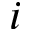<formula> <loc_0><loc_0><loc_500><loc_500>i</formula> 